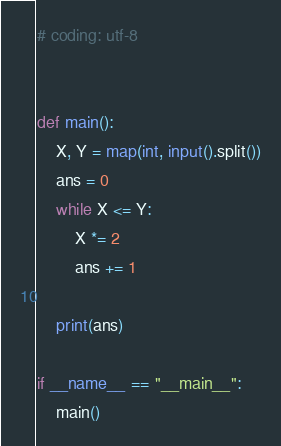<code> <loc_0><loc_0><loc_500><loc_500><_Python_># coding: utf-8


def main():
    X, Y = map(int, input().split())
    ans = 0
    while X <= Y:
        X *= 2
        ans += 1

    print(ans)

if __name__ == "__main__":
    main()
</code> 